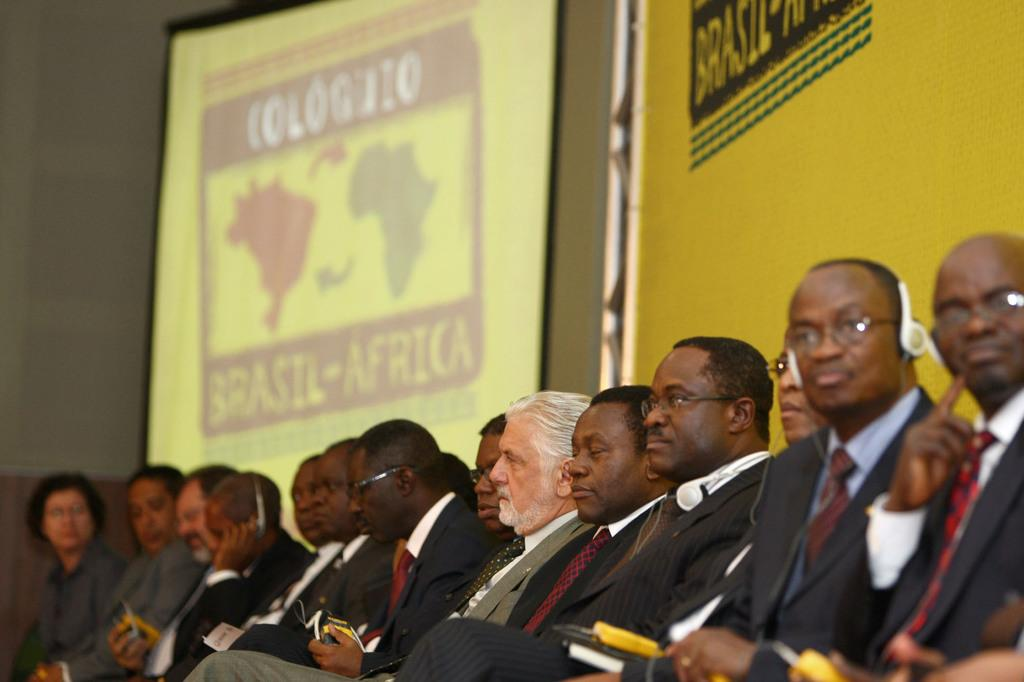What is happening in the foreground of the image? There are people sitting in the foreground of the image. What are some of the people doing in the image? Some of the people are holding objects, and some are wearing headsets. What can be seen on the wall in the background of the image? There is a screen on the wall in the background of the image. What type of meat is being cooked on the cast in the image? There is no cast or meat present in the image; it features people sitting and holding objects, as well as a screen on the wall. 